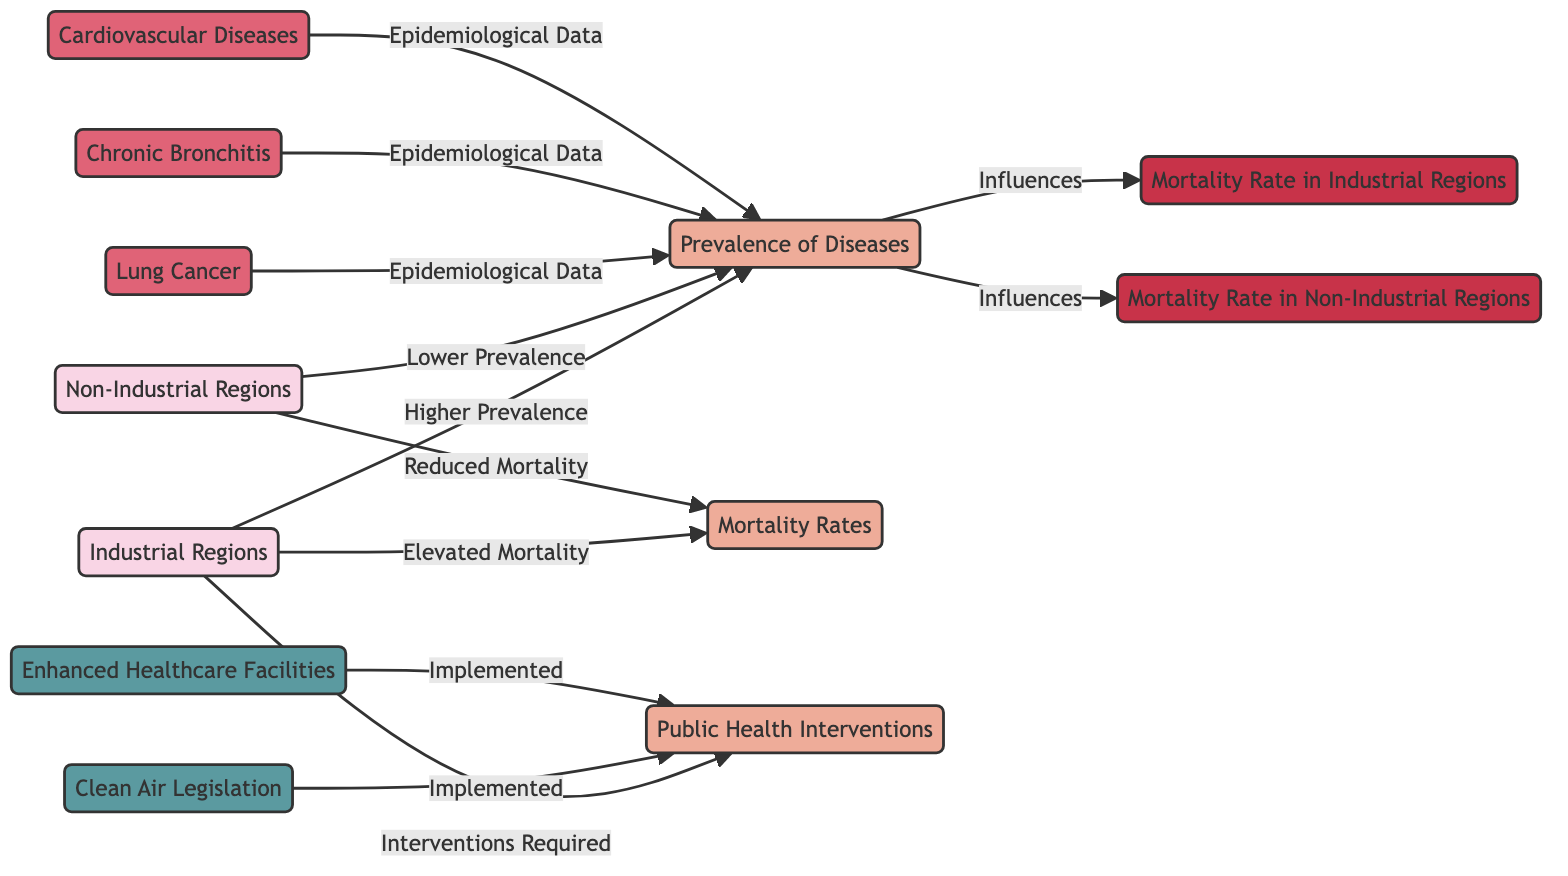What is indicated as a higher health issue in industrial regions? The diagram states that industrial regions have a "Higher Prevalence" of diseases compared to non-industrial regions. This specifically relates to the aforementioned health issues.
Answer: Higher Prevalence What diseases are part of the epidemiological data referenced in the diagram? The diseases listed that contribute to the epidemiological data are lung cancer, chronic bronchitis, and cardiovascular diseases. These are specifically grouped in the diagram's flow.
Answer: Lung Cancer, Chronic Bronchitis, Cardiovascular Diseases How do the mortality rates in non-industrial regions compare to those in industrial regions? The diagram indicates that non-industrial regions have a "Reduced Mortality," while industrial regions have "Elevated Mortality." This contrasts the health outcomes in the two types of regions.
Answer: Reduced Mortality What public health intervention is mentioned as implemented in both region types? The diagram lists "Clean Air Legislation" and "Enhanced Healthcare Facilities" under public health interventions, indicating these efforts are addressed in both industrial and non-industrial contexts.
Answer: Clean Air Legislation, Enhanced Healthcare Facilities Which node influences the mortality rates in both industrial and non-industrial regions? The "Prevalence of Diseases" affects the mortality rates. This is indicated by the directed flow from the prevalence aspect to both mortality aspects in the diagram.
Answer: Prevalence of Diseases What is the primary relationship shown between industrial regions and public health interventions? The diagram shows that industrial regions have "Interventions Required," which implies a need for public health interventions due to the elevated health risks observed.
Answer: Interventions Required How many diseases are specifically mentioned in the influence of epidemiological data? Three diseases are specifically mentioned in the epidemiological data that flow into the prevalence aspect of industrial regions. This includes lung cancer, chronic bronchitis, and cardiovascular diseases.
Answer: Three Diseases What trend is observed regarding mortality rates in both regions over time? The diagram indicates that industrial regions experience "Elevated Mortality," while non-industrial regions show "Reduced Mortality," suggesting a trend favoring health sustainability in non-industrial areas.
Answer: Elevated Mortality and Reduced Mortality 